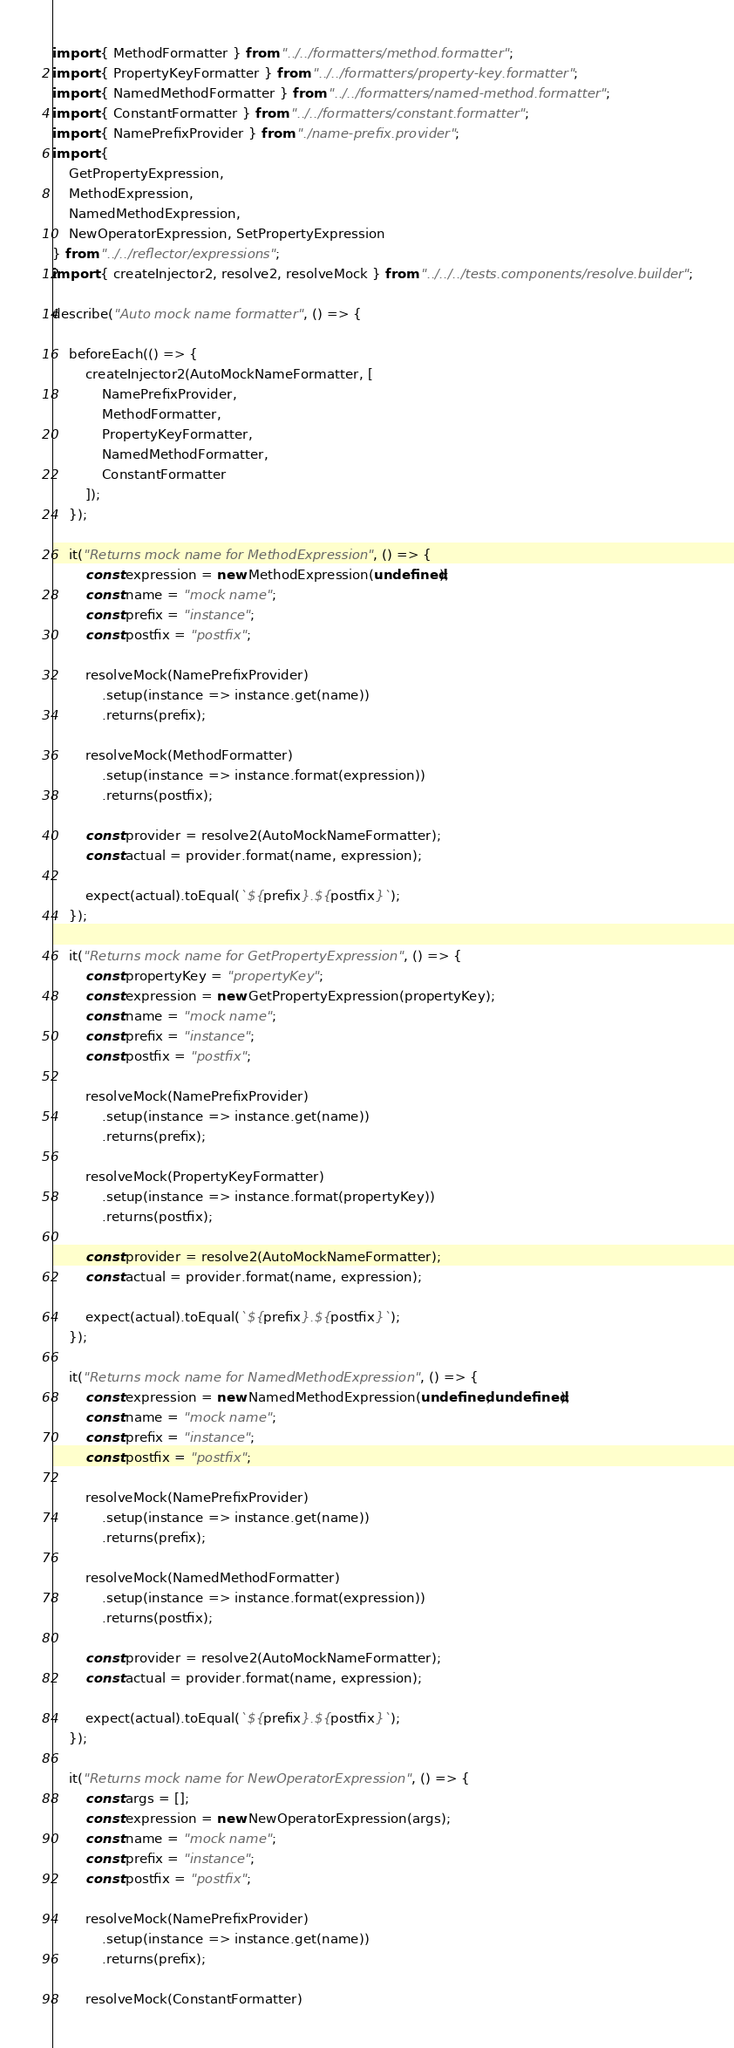Convert code to text. <code><loc_0><loc_0><loc_500><loc_500><_TypeScript_>import { MethodFormatter } from "../../formatters/method.formatter";
import { PropertyKeyFormatter } from "../../formatters/property-key.formatter";
import { NamedMethodFormatter } from "../../formatters/named-method.formatter";
import { ConstantFormatter } from "../../formatters/constant.formatter";
import { NamePrefixProvider } from "./name-prefix.provider";
import {
    GetPropertyExpression,
    MethodExpression,
    NamedMethodExpression,
    NewOperatorExpression, SetPropertyExpression
} from "../../reflector/expressions";
import { createInjector2, resolve2, resolveMock } from "../../../tests.components/resolve.builder";

describe("Auto mock name formatter", () => {

    beforeEach(() => {
        createInjector2(AutoMockNameFormatter, [
            NamePrefixProvider,
            MethodFormatter,
            PropertyKeyFormatter,
            NamedMethodFormatter,
            ConstantFormatter
        ]);
    });

    it("Returns mock name for MethodExpression", () => {
        const expression = new MethodExpression(undefined);
        const name = "mock name";
        const prefix = "instance";
        const postfix = "postfix";

        resolveMock(NamePrefixProvider)
            .setup(instance => instance.get(name))
            .returns(prefix);

        resolveMock(MethodFormatter)
            .setup(instance => instance.format(expression))
            .returns(postfix);

        const provider = resolve2(AutoMockNameFormatter);
        const actual = provider.format(name, expression);

        expect(actual).toEqual(`${prefix}.${postfix}`);
    });

    it("Returns mock name for GetPropertyExpression", () => {
        const propertyKey = "propertyKey";
        const expression = new GetPropertyExpression(propertyKey);
        const name = "mock name";
        const prefix = "instance";
        const postfix = "postfix";

        resolveMock(NamePrefixProvider)
            .setup(instance => instance.get(name))
            .returns(prefix);

        resolveMock(PropertyKeyFormatter)
            .setup(instance => instance.format(propertyKey))
            .returns(postfix);

        const provider = resolve2(AutoMockNameFormatter);
        const actual = provider.format(name, expression);

        expect(actual).toEqual(`${prefix}.${postfix}`);
    });

    it("Returns mock name for NamedMethodExpression", () => {
        const expression = new NamedMethodExpression(undefined, undefined);
        const name = "mock name";
        const prefix = "instance";
        const postfix = "postfix";

        resolveMock(NamePrefixProvider)
            .setup(instance => instance.get(name))
            .returns(prefix);

        resolveMock(NamedMethodFormatter)
            .setup(instance => instance.format(expression))
            .returns(postfix);

        const provider = resolve2(AutoMockNameFormatter);
        const actual = provider.format(name, expression);

        expect(actual).toEqual(`${prefix}.${postfix}`);
    });

    it("Returns mock name for NewOperatorExpression", () => {
        const args = [];
        const expression = new NewOperatorExpression(args);
        const name = "mock name";
        const prefix = "instance";
        const postfix = "postfix";

        resolveMock(NamePrefixProvider)
            .setup(instance => instance.get(name))
            .returns(prefix);

        resolveMock(ConstantFormatter)</code> 